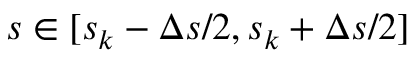<formula> <loc_0><loc_0><loc_500><loc_500>s \in [ s _ { k } - \Delta s / 2 , s _ { k } + \Delta s / 2 ]</formula> 